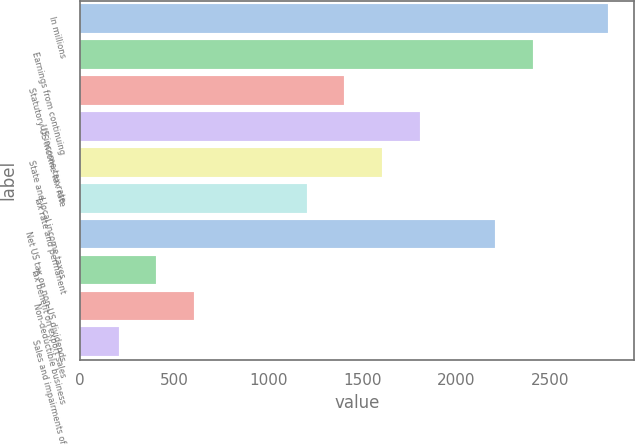Convert chart to OTSL. <chart><loc_0><loc_0><loc_500><loc_500><bar_chart><fcel>In millions<fcel>Earnings from continuing<fcel>Statutory US income tax rate<fcel>US income tax rate<fcel>State and local income taxes<fcel>Tax rate and permanent<fcel>Net US tax on non-US dividends<fcel>Tax benefit on export sales<fcel>Non-deductible business<fcel>Sales and impairments of<nl><fcel>2804.6<fcel>2404.8<fcel>1405.3<fcel>1805.1<fcel>1605.2<fcel>1205.4<fcel>2204.9<fcel>405.8<fcel>605.7<fcel>205.9<nl></chart> 